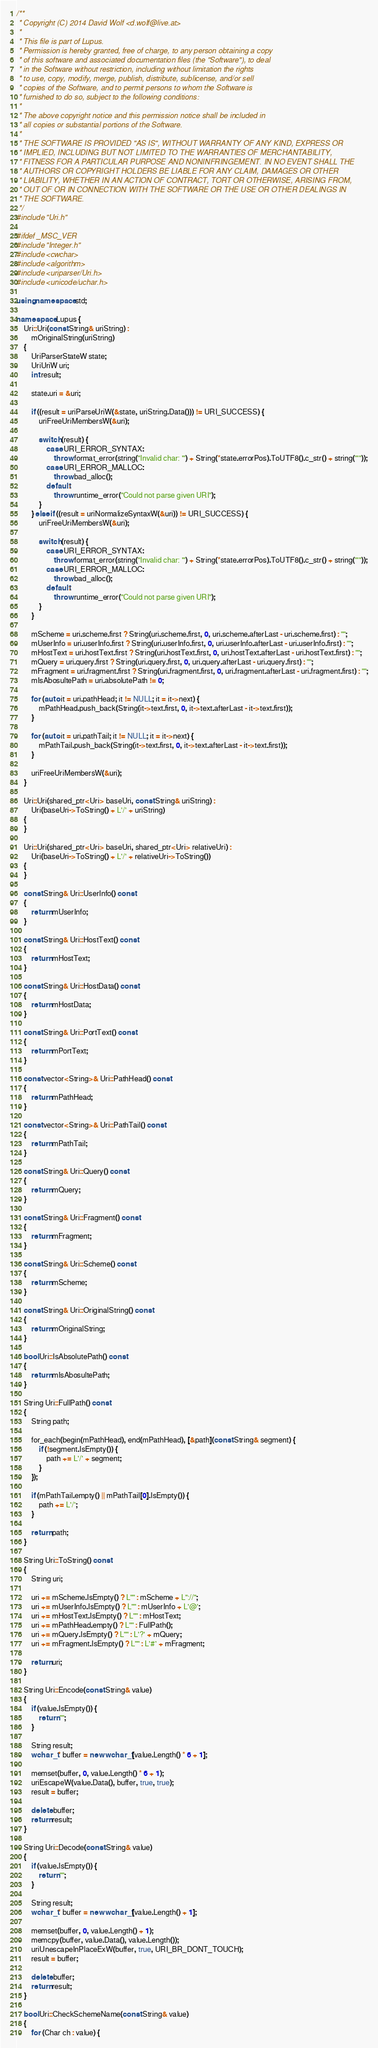<code> <loc_0><loc_0><loc_500><loc_500><_C++_>/**
 * Copyright (C) 2014 David Wolf <d.wolf@live.at>
 *
 * This file is part of Lupus.
 * Permission is hereby granted, free of charge, to any person obtaining a copy
 * of this software and associated documentation files (the "Software"), to deal
 * in the Software without restriction, including without limitation the rights
 * to use, copy, modify, merge, publish, distribute, sublicense, and/or sell
 * copies of the Software, and to permit persons to whom the Software is
 * furnished to do so, subject to the following conditions:
 *
 * The above copyright notice and this permission notice shall be included in
 * all copies or substantial portions of the Software.
 *
 * THE SOFTWARE IS PROVIDED "AS IS", WITHOUT WARRANTY OF ANY KIND, EXPRESS OR
 * IMPLIED, INCLUDING BUT NOT LIMITED TO THE WARRANTIES OF MERCHANTABILITY,
 * FITNESS FOR A PARTICULAR PURPOSE AND NONINFRINGEMENT. IN NO EVENT SHALL THE
 * AUTHORS OR COPYRIGHT HOLDERS BE LIABLE FOR ANY CLAIM, DAMAGES OR OTHER
 * LIABILITY, WHETHER IN AN ACTION OF CONTRACT, TORT OR OTHERWISE, ARISING FROM,
 * OUT OF OR IN CONNECTION WITH THE SOFTWARE OR THE USE OR OTHER DEALINGS IN
 * THE SOFTWARE.
 */
#include "Uri.h"

#ifdef _MSC_VER
#include "Integer.h"
#include <cwchar>
#include <algorithm>
#include <uriparser/Uri.h>
#include <unicode/uchar.h>

using namespace std;

namespace Lupus {
    Uri::Uri(const String& uriString) :
        mOriginalString(uriString)
    {
        UriParserStateW state;
        UriUriW uri;
        int result;

        state.uri = &uri;

        if ((result = uriParseUriW(&state, uriString.Data())) != URI_SUCCESS) {
            uriFreeUriMembersW(&uri);

            switch (result) {
                case URI_ERROR_SYNTAX:
                    throw format_error(string("Invalid char: '") + String(*state.errorPos).ToUTF8().c_str() + string("'"));
                case URI_ERROR_MALLOC:
                    throw bad_alloc();
                default:
                    throw runtime_error("Could not parse given URI");
            }
        } else if ((result = uriNormalizeSyntaxW(&uri)) != URI_SUCCESS) {
            uriFreeUriMembersW(&uri);

            switch (result) {
                case URI_ERROR_SYNTAX:
                    throw format_error(string("Invalid char: '") + String(*state.errorPos).ToUTF8().c_str() + string("'"));
                case URI_ERROR_MALLOC:
                    throw bad_alloc();
                default:
                    throw runtime_error("Could not parse given URI");
            }
        }

        mScheme = uri.scheme.first ? String(uri.scheme.first, 0, uri.scheme.afterLast - uri.scheme.first) : "";
        mUserInfo = uri.userInfo.first ? String(uri.userInfo.first, 0, uri.userInfo.afterLast - uri.userInfo.first) : "";
        mHostText = uri.hostText.first ? String(uri.hostText.first, 0, uri.hostText.afterLast - uri.hostText.first) : "";
        mQuery = uri.query.first ? String(uri.query.first, 0, uri.query.afterLast - uri.query.first) : "";
        mFragment = uri.fragment.first ? String(uri.fragment.first, 0, uri.fragment.afterLast - uri.fragment.first) : "";
        mIsAbosultePath = uri.absolutePath != 0;

        for (auto it = uri.pathHead; it != NULL; it = it->next) {
            mPathHead.push_back(String(it->text.first, 0, it->text.afterLast - it->text.first));
        }

        for (auto it = uri.pathTail; it != NULL; it = it->next) {
            mPathTail.push_back(String(it->text.first, 0, it->text.afterLast - it->text.first));
        }

        uriFreeUriMembersW(&uri);
    }

    Uri::Uri(shared_ptr<Uri> baseUri, const String& uriString) :
        Uri(baseUri->ToString() + L'/' + uriString)
    {
    }

    Uri::Uri(shared_ptr<Uri> baseUri, shared_ptr<Uri> relativeUri) :
        Uri(baseUri->ToString() + L'/' + relativeUri->ToString())
    {
    }

    const String& Uri::UserInfo() const
    {
        return mUserInfo;
    }

    const String& Uri::HostText() const
    {
        return mHostText;
    }

    const String& Uri::HostData() const
    {
        return mHostData;
    }

    const String& Uri::PortText() const
    {
        return mPortText;
    }

    const vector<String>& Uri::PathHead() const
    {
        return mPathHead;
    }

    const vector<String>& Uri::PathTail() const
    {
        return mPathTail;
    }

    const String& Uri::Query() const
    {
        return mQuery;
    }

    const String& Uri::Fragment() const
    {
        return mFragment;
    }

    const String& Uri::Scheme() const
    {
        return mScheme;
    }

    const String& Uri::OriginalString() const
    {
        return mOriginalString;
    }

    bool Uri::IsAbsolutePath() const
    {
        return mIsAbosultePath;
    }

    String Uri::FullPath() const
    {
        String path;

        for_each(begin(mPathHead), end(mPathHead), [&path](const String& segment) {
            if (!segment.IsEmpty()) {
                path += L'/' + segment;
            }
        });

        if (mPathTail.empty() || mPathTail[0].IsEmpty()) {
            path += L'/';
        }

        return path;
    }

    String Uri::ToString() const
    {
        String uri;

        uri += mScheme.IsEmpty() ? L"" : mScheme + L"://";
        uri += mUserInfo.IsEmpty() ? L"" : mUserInfo + L'@';
        uri += mHostText.IsEmpty() ? L"" : mHostText;
        uri += mPathHead.empty() ? L"" : FullPath();
        uri += mQuery.IsEmpty() ? L"" : L'?' + mQuery;
        uri += mFragment.IsEmpty() ? L"" : L'#' + mFragment;

        return uri;
    }

    String Uri::Encode(const String& value)
    {
        if (value.IsEmpty()) {
            return "";
        }

        String result;
        wchar_t* buffer = new wchar_t[value.Length() * 6 + 1];

        memset(buffer, 0, value.Length() * 6 + 1);
        uriEscapeW(value.Data(), buffer, true, true);
        result = buffer;
        
        delete buffer;
        return result;
    }

    String Uri::Decode(const String& value)
    {
        if (value.IsEmpty()) {
            return "";
        }

        String result;
        wchar_t* buffer = new wchar_t[value.Length() + 1];
        
        memset(buffer, 0, value.Length() + 1);
        memcpy(buffer, value.Data(), value.Length());
        uriUnescapeInPlaceExW(buffer, true, URI_BR_DONT_TOUCH);
        result = buffer;

        delete buffer;
        return result;
    }

    bool Uri::CheckSchemeName(const String& value)
    {
        for (Char ch : value) {</code> 